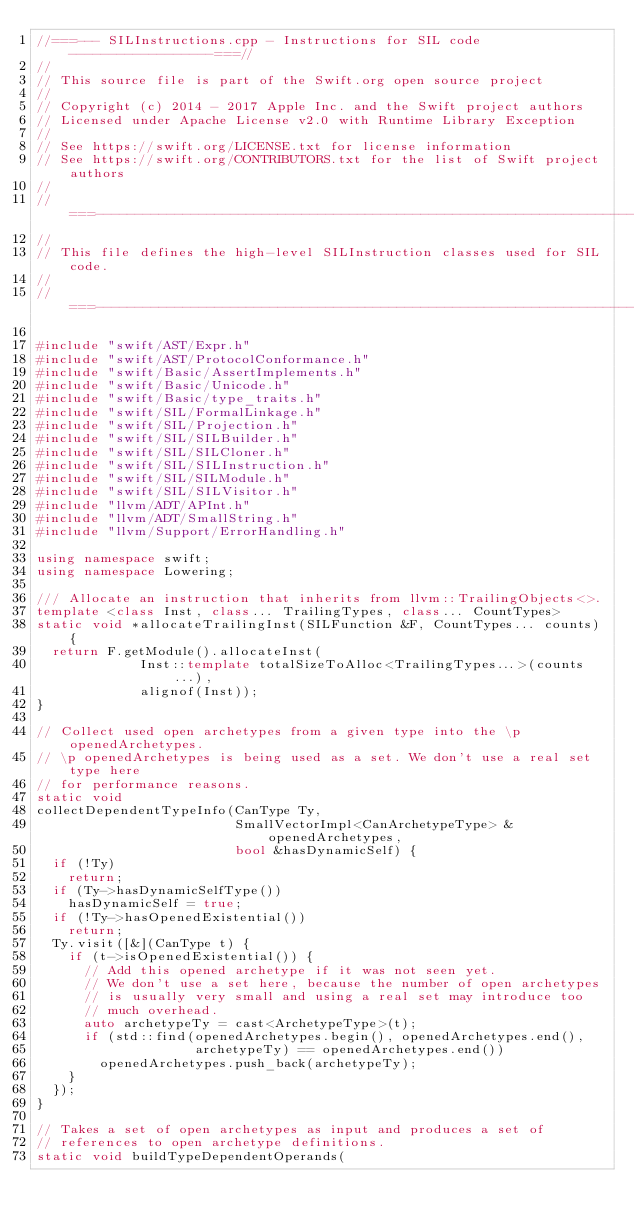Convert code to text. <code><loc_0><loc_0><loc_500><loc_500><_C++_>//===--- SILInstructions.cpp - Instructions for SIL code ------------------===//
//
// This source file is part of the Swift.org open source project
//
// Copyright (c) 2014 - 2017 Apple Inc. and the Swift project authors
// Licensed under Apache License v2.0 with Runtime Library Exception
//
// See https://swift.org/LICENSE.txt for license information
// See https://swift.org/CONTRIBUTORS.txt for the list of Swift project authors
//
//===----------------------------------------------------------------------===//
//
// This file defines the high-level SILInstruction classes used for SIL code.
//
//===----------------------------------------------------------------------===//

#include "swift/AST/Expr.h"
#include "swift/AST/ProtocolConformance.h"
#include "swift/Basic/AssertImplements.h"
#include "swift/Basic/Unicode.h"
#include "swift/Basic/type_traits.h"
#include "swift/SIL/FormalLinkage.h"
#include "swift/SIL/Projection.h"
#include "swift/SIL/SILBuilder.h"
#include "swift/SIL/SILCloner.h"
#include "swift/SIL/SILInstruction.h"
#include "swift/SIL/SILModule.h"
#include "swift/SIL/SILVisitor.h"
#include "llvm/ADT/APInt.h"
#include "llvm/ADT/SmallString.h"
#include "llvm/Support/ErrorHandling.h"

using namespace swift;
using namespace Lowering;

/// Allocate an instruction that inherits from llvm::TrailingObjects<>.
template <class Inst, class... TrailingTypes, class... CountTypes>
static void *allocateTrailingInst(SILFunction &F, CountTypes... counts) {
  return F.getModule().allocateInst(
             Inst::template totalSizeToAlloc<TrailingTypes...>(counts...),
             alignof(Inst));
}

// Collect used open archetypes from a given type into the \p openedArchetypes.
// \p openedArchetypes is being used as a set. We don't use a real set type here
// for performance reasons.
static void
collectDependentTypeInfo(CanType Ty,
                         SmallVectorImpl<CanArchetypeType> &openedArchetypes,
                         bool &hasDynamicSelf) {
  if (!Ty)
    return;
  if (Ty->hasDynamicSelfType())
    hasDynamicSelf = true;
  if (!Ty->hasOpenedExistential())
    return;
  Ty.visit([&](CanType t) {
    if (t->isOpenedExistential()) {
      // Add this opened archetype if it was not seen yet.
      // We don't use a set here, because the number of open archetypes
      // is usually very small and using a real set may introduce too
      // much overhead.
      auto archetypeTy = cast<ArchetypeType>(t);
      if (std::find(openedArchetypes.begin(), openedArchetypes.end(),
                    archetypeTy) == openedArchetypes.end())
        openedArchetypes.push_back(archetypeTy);
    }
  });
}

// Takes a set of open archetypes as input and produces a set of
// references to open archetype definitions.
static void buildTypeDependentOperands(</code> 